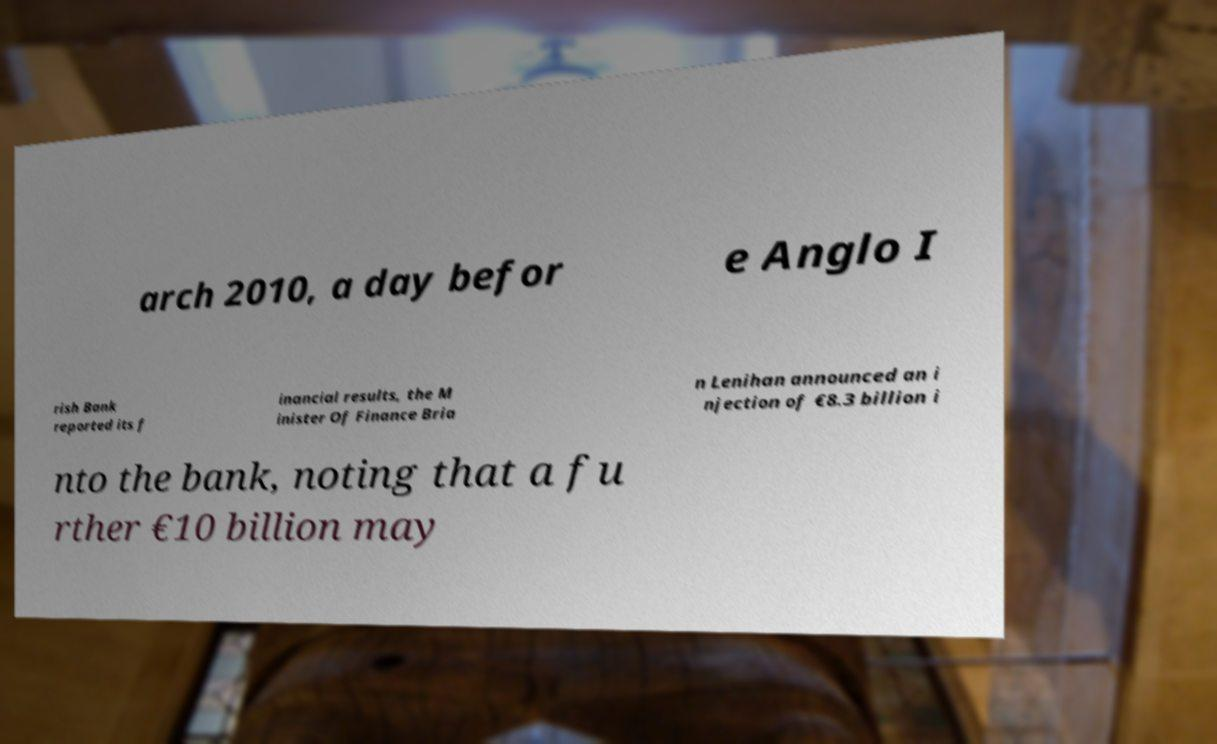Please identify and transcribe the text found in this image. arch 2010, a day befor e Anglo I rish Bank reported its f inancial results, the M inister Of Finance Bria n Lenihan announced an i njection of €8.3 billion i nto the bank, noting that a fu rther €10 billion may 